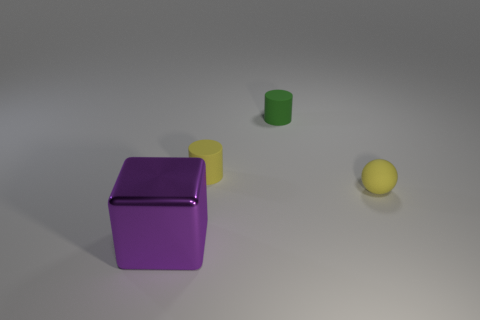Add 1 small yellow matte spheres. How many objects exist? 5 Subtract all cubes. How many objects are left? 3 Subtract all purple metallic objects. Subtract all big metallic objects. How many objects are left? 2 Add 1 small matte cylinders. How many small matte cylinders are left? 3 Add 3 gray cylinders. How many gray cylinders exist? 3 Subtract 0 yellow cubes. How many objects are left? 4 